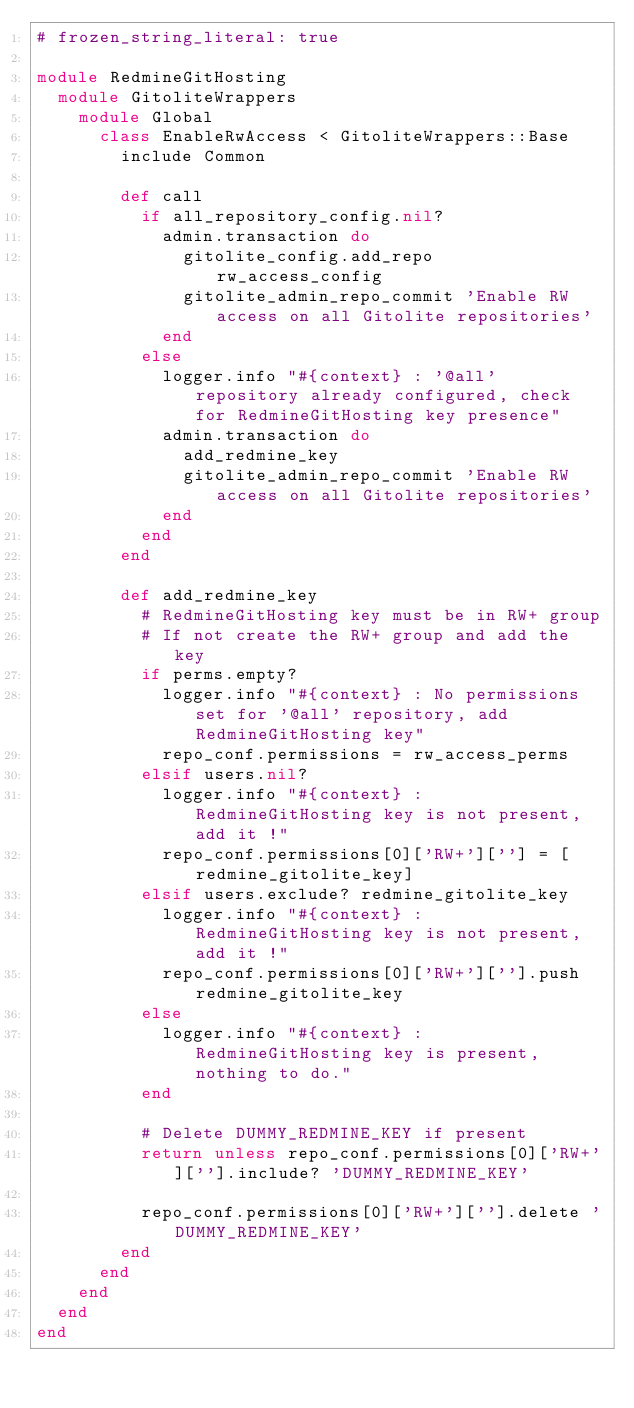Convert code to text. <code><loc_0><loc_0><loc_500><loc_500><_Ruby_># frozen_string_literal: true

module RedmineGitHosting
  module GitoliteWrappers
    module Global
      class EnableRwAccess < GitoliteWrappers::Base
        include Common

        def call
          if all_repository_config.nil?
            admin.transaction do
              gitolite_config.add_repo rw_access_config
              gitolite_admin_repo_commit 'Enable RW access on all Gitolite repositories'
            end
          else
            logger.info "#{context} : '@all' repository already configured, check for RedmineGitHosting key presence"
            admin.transaction do
              add_redmine_key
              gitolite_admin_repo_commit 'Enable RW access on all Gitolite repositories'
            end
          end
        end

        def add_redmine_key
          # RedmineGitHosting key must be in RW+ group
          # If not create the RW+ group and add the key
          if perms.empty?
            logger.info "#{context} : No permissions set for '@all' repository, add RedmineGitHosting key"
            repo_conf.permissions = rw_access_perms
          elsif users.nil?
            logger.info "#{context} : RedmineGitHosting key is not present, add it !"
            repo_conf.permissions[0]['RW+'][''] = [redmine_gitolite_key]
          elsif users.exclude? redmine_gitolite_key
            logger.info "#{context} : RedmineGitHosting key is not present, add it !"
            repo_conf.permissions[0]['RW+'][''].push redmine_gitolite_key
          else
            logger.info "#{context} : RedmineGitHosting key is present, nothing to do."
          end

          # Delete DUMMY_REDMINE_KEY if present
          return unless repo_conf.permissions[0]['RW+'][''].include? 'DUMMY_REDMINE_KEY'

          repo_conf.permissions[0]['RW+'][''].delete 'DUMMY_REDMINE_KEY'
        end
      end
    end
  end
end
</code> 